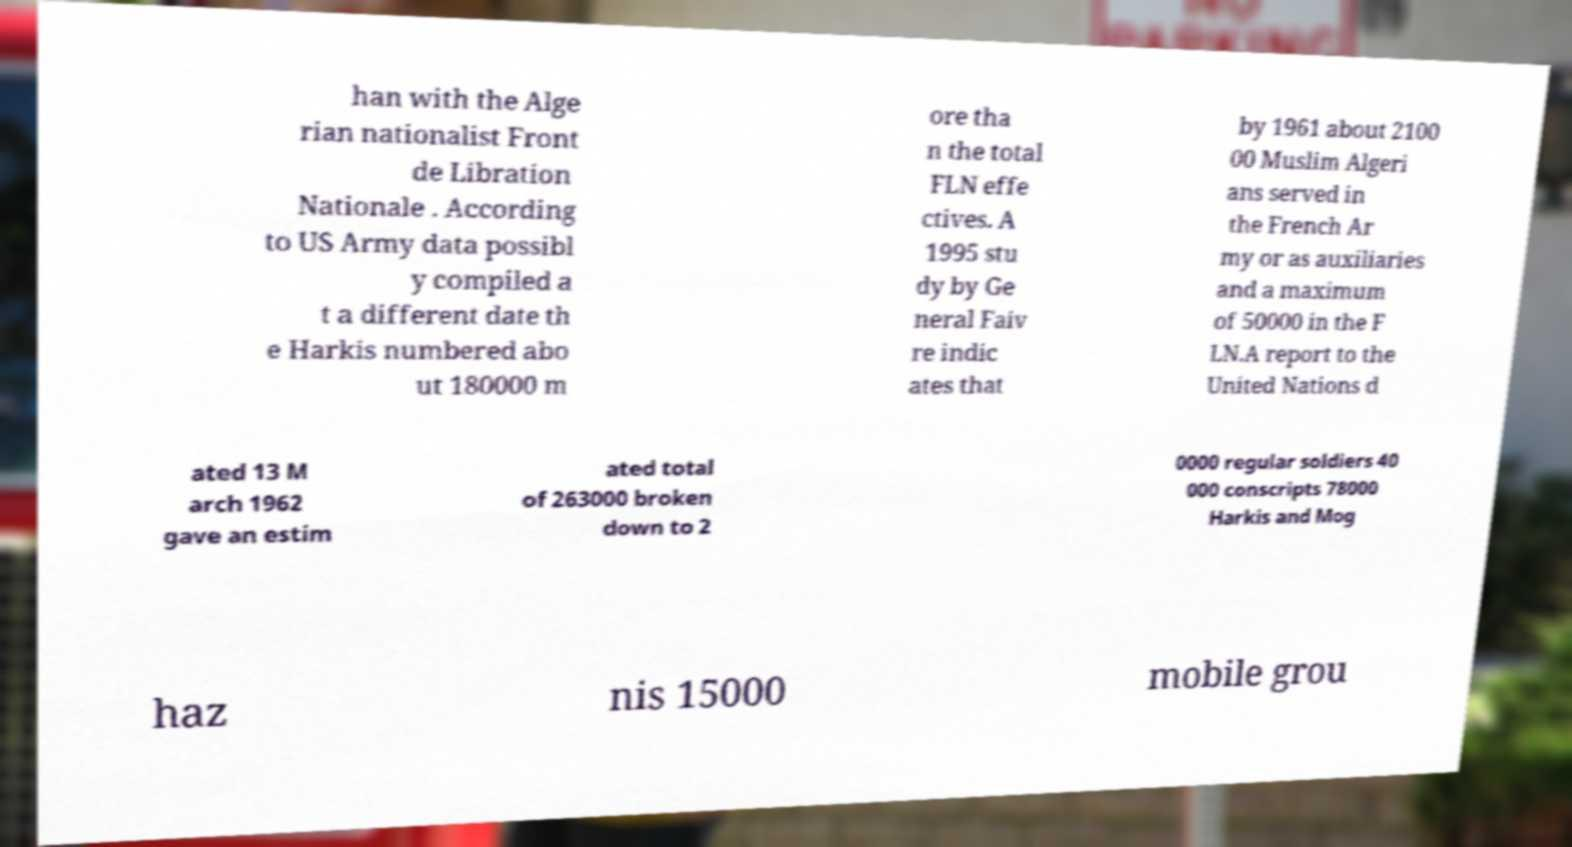Can you read and provide the text displayed in the image?This photo seems to have some interesting text. Can you extract and type it out for me? han with the Alge rian nationalist Front de Libration Nationale . According to US Army data possibl y compiled a t a different date th e Harkis numbered abo ut 180000 m ore tha n the total FLN effe ctives. A 1995 stu dy by Ge neral Faiv re indic ates that by 1961 about 2100 00 Muslim Algeri ans served in the French Ar my or as auxiliaries and a maximum of 50000 in the F LN.A report to the United Nations d ated 13 M arch 1962 gave an estim ated total of 263000 broken down to 2 0000 regular soldiers 40 000 conscripts 78000 Harkis and Mog haz nis 15000 mobile grou 